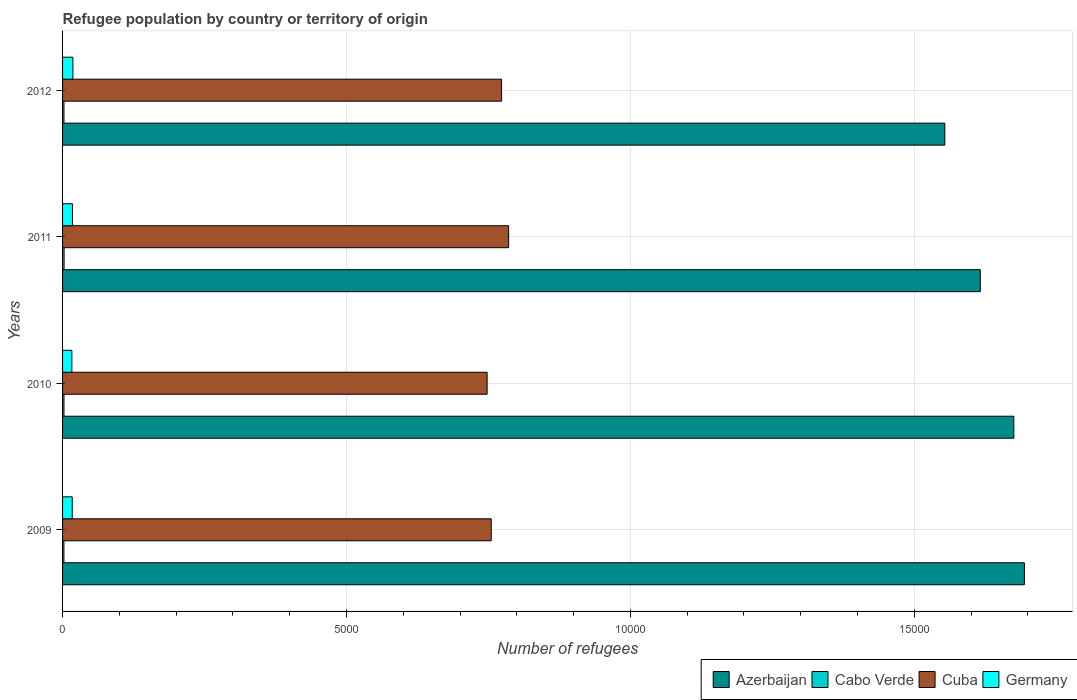How many groups of bars are there?
Keep it short and to the point. 4. Are the number of bars per tick equal to the number of legend labels?
Give a very brief answer. Yes. How many bars are there on the 3rd tick from the bottom?
Your answer should be compact. 4. What is the number of refugees in Cabo Verde in 2011?
Your answer should be very brief. 27. Across all years, what is the maximum number of refugees in Cuba?
Give a very brief answer. 7856. Across all years, what is the minimum number of refugees in Cuba?
Provide a succinct answer. 7477. In which year was the number of refugees in Germany minimum?
Your response must be concise. 2010. What is the total number of refugees in Germany in the graph?
Give a very brief answer. 690. What is the difference between the number of refugees in Cuba in 2010 and that in 2012?
Your answer should be compact. -254. What is the difference between the number of refugees in Germany in 2009 and the number of refugees in Azerbaijan in 2011?
Your answer should be very brief. -1.60e+04. What is the average number of refugees in Germany per year?
Give a very brief answer. 172.5. In the year 2009, what is the difference between the number of refugees in Azerbaijan and number of refugees in Germany?
Give a very brief answer. 1.68e+04. What is the ratio of the number of refugees in Cabo Verde in 2009 to that in 2011?
Give a very brief answer. 0.89. Is the number of refugees in Cuba in 2010 less than that in 2012?
Your answer should be compact. Yes. Is the difference between the number of refugees in Azerbaijan in 2009 and 2011 greater than the difference between the number of refugees in Germany in 2009 and 2011?
Your response must be concise. Yes. What is the difference between the highest and the second highest number of refugees in Cabo Verde?
Provide a short and direct response. 2. What is the difference between the highest and the lowest number of refugees in Cuba?
Provide a succinct answer. 379. Is it the case that in every year, the sum of the number of refugees in Cuba and number of refugees in Cabo Verde is greater than the sum of number of refugees in Germany and number of refugees in Azerbaijan?
Give a very brief answer. Yes. What does the 4th bar from the top in 2009 represents?
Your response must be concise. Azerbaijan. What does the 1st bar from the bottom in 2011 represents?
Provide a short and direct response. Azerbaijan. How many bars are there?
Your response must be concise. 16. How many years are there in the graph?
Provide a short and direct response. 4. What is the difference between two consecutive major ticks on the X-axis?
Provide a succinct answer. 5000. Does the graph contain any zero values?
Your response must be concise. No. Does the graph contain grids?
Ensure brevity in your answer.  Yes. Where does the legend appear in the graph?
Keep it short and to the point. Bottom right. What is the title of the graph?
Offer a terse response. Refugee population by country or territory of origin. What is the label or title of the X-axis?
Your answer should be very brief. Number of refugees. What is the label or title of the Y-axis?
Offer a very short reply. Years. What is the Number of refugees in Azerbaijan in 2009?
Your answer should be very brief. 1.69e+04. What is the Number of refugees in Cuba in 2009?
Keep it short and to the point. 7549. What is the Number of refugees of Germany in 2009?
Keep it short and to the point. 170. What is the Number of refugees of Azerbaijan in 2010?
Your answer should be compact. 1.68e+04. What is the Number of refugees of Cuba in 2010?
Your answer should be compact. 7477. What is the Number of refugees in Germany in 2010?
Your answer should be very brief. 164. What is the Number of refugees of Azerbaijan in 2011?
Offer a terse response. 1.62e+04. What is the Number of refugees of Cabo Verde in 2011?
Provide a succinct answer. 27. What is the Number of refugees of Cuba in 2011?
Ensure brevity in your answer.  7856. What is the Number of refugees in Germany in 2011?
Your response must be concise. 174. What is the Number of refugees of Azerbaijan in 2012?
Your answer should be compact. 1.55e+04. What is the Number of refugees in Cuba in 2012?
Your answer should be very brief. 7731. What is the Number of refugees in Germany in 2012?
Give a very brief answer. 182. Across all years, what is the maximum Number of refugees in Azerbaijan?
Offer a terse response. 1.69e+04. Across all years, what is the maximum Number of refugees in Cuba?
Keep it short and to the point. 7856. Across all years, what is the maximum Number of refugees in Germany?
Ensure brevity in your answer.  182. Across all years, what is the minimum Number of refugees in Azerbaijan?
Your response must be concise. 1.55e+04. Across all years, what is the minimum Number of refugees of Cabo Verde?
Keep it short and to the point. 24. Across all years, what is the minimum Number of refugees of Cuba?
Offer a terse response. 7477. Across all years, what is the minimum Number of refugees in Germany?
Your answer should be very brief. 164. What is the total Number of refugees of Azerbaijan in the graph?
Make the answer very short. 6.54e+04. What is the total Number of refugees of Cabo Verde in the graph?
Provide a succinct answer. 101. What is the total Number of refugees of Cuba in the graph?
Give a very brief answer. 3.06e+04. What is the total Number of refugees of Germany in the graph?
Your answer should be very brief. 690. What is the difference between the Number of refugees of Azerbaijan in 2009 and that in 2010?
Offer a very short reply. 186. What is the difference between the Number of refugees of Azerbaijan in 2009 and that in 2011?
Provide a succinct answer. 777. What is the difference between the Number of refugees in Cuba in 2009 and that in 2011?
Keep it short and to the point. -307. What is the difference between the Number of refugees of Azerbaijan in 2009 and that in 2012?
Ensure brevity in your answer.  1402. What is the difference between the Number of refugees in Cuba in 2009 and that in 2012?
Keep it short and to the point. -182. What is the difference between the Number of refugees in Germany in 2009 and that in 2012?
Keep it short and to the point. -12. What is the difference between the Number of refugees in Azerbaijan in 2010 and that in 2011?
Keep it short and to the point. 591. What is the difference between the Number of refugees of Cuba in 2010 and that in 2011?
Give a very brief answer. -379. What is the difference between the Number of refugees in Germany in 2010 and that in 2011?
Keep it short and to the point. -10. What is the difference between the Number of refugees of Azerbaijan in 2010 and that in 2012?
Ensure brevity in your answer.  1216. What is the difference between the Number of refugees of Cabo Verde in 2010 and that in 2012?
Keep it short and to the point. 0. What is the difference between the Number of refugees in Cuba in 2010 and that in 2012?
Your answer should be very brief. -254. What is the difference between the Number of refugees in Germany in 2010 and that in 2012?
Your answer should be very brief. -18. What is the difference between the Number of refugees in Azerbaijan in 2011 and that in 2012?
Your response must be concise. 625. What is the difference between the Number of refugees of Cabo Verde in 2011 and that in 2012?
Your response must be concise. 2. What is the difference between the Number of refugees in Cuba in 2011 and that in 2012?
Make the answer very short. 125. What is the difference between the Number of refugees in Azerbaijan in 2009 and the Number of refugees in Cabo Verde in 2010?
Give a very brief answer. 1.69e+04. What is the difference between the Number of refugees of Azerbaijan in 2009 and the Number of refugees of Cuba in 2010?
Make the answer very short. 9462. What is the difference between the Number of refugees of Azerbaijan in 2009 and the Number of refugees of Germany in 2010?
Your answer should be compact. 1.68e+04. What is the difference between the Number of refugees in Cabo Verde in 2009 and the Number of refugees in Cuba in 2010?
Your answer should be compact. -7453. What is the difference between the Number of refugees in Cabo Verde in 2009 and the Number of refugees in Germany in 2010?
Provide a short and direct response. -140. What is the difference between the Number of refugees in Cuba in 2009 and the Number of refugees in Germany in 2010?
Offer a terse response. 7385. What is the difference between the Number of refugees in Azerbaijan in 2009 and the Number of refugees in Cabo Verde in 2011?
Provide a short and direct response. 1.69e+04. What is the difference between the Number of refugees of Azerbaijan in 2009 and the Number of refugees of Cuba in 2011?
Offer a terse response. 9083. What is the difference between the Number of refugees in Azerbaijan in 2009 and the Number of refugees in Germany in 2011?
Offer a very short reply. 1.68e+04. What is the difference between the Number of refugees of Cabo Verde in 2009 and the Number of refugees of Cuba in 2011?
Offer a terse response. -7832. What is the difference between the Number of refugees in Cabo Verde in 2009 and the Number of refugees in Germany in 2011?
Keep it short and to the point. -150. What is the difference between the Number of refugees in Cuba in 2009 and the Number of refugees in Germany in 2011?
Provide a succinct answer. 7375. What is the difference between the Number of refugees in Azerbaijan in 2009 and the Number of refugees in Cabo Verde in 2012?
Keep it short and to the point. 1.69e+04. What is the difference between the Number of refugees in Azerbaijan in 2009 and the Number of refugees in Cuba in 2012?
Keep it short and to the point. 9208. What is the difference between the Number of refugees of Azerbaijan in 2009 and the Number of refugees of Germany in 2012?
Provide a succinct answer. 1.68e+04. What is the difference between the Number of refugees of Cabo Verde in 2009 and the Number of refugees of Cuba in 2012?
Your answer should be compact. -7707. What is the difference between the Number of refugees in Cabo Verde in 2009 and the Number of refugees in Germany in 2012?
Ensure brevity in your answer.  -158. What is the difference between the Number of refugees of Cuba in 2009 and the Number of refugees of Germany in 2012?
Provide a succinct answer. 7367. What is the difference between the Number of refugees in Azerbaijan in 2010 and the Number of refugees in Cabo Verde in 2011?
Provide a succinct answer. 1.67e+04. What is the difference between the Number of refugees of Azerbaijan in 2010 and the Number of refugees of Cuba in 2011?
Your answer should be compact. 8897. What is the difference between the Number of refugees of Azerbaijan in 2010 and the Number of refugees of Germany in 2011?
Offer a terse response. 1.66e+04. What is the difference between the Number of refugees of Cabo Verde in 2010 and the Number of refugees of Cuba in 2011?
Give a very brief answer. -7831. What is the difference between the Number of refugees of Cabo Verde in 2010 and the Number of refugees of Germany in 2011?
Your answer should be compact. -149. What is the difference between the Number of refugees in Cuba in 2010 and the Number of refugees in Germany in 2011?
Your response must be concise. 7303. What is the difference between the Number of refugees in Azerbaijan in 2010 and the Number of refugees in Cabo Verde in 2012?
Make the answer very short. 1.67e+04. What is the difference between the Number of refugees of Azerbaijan in 2010 and the Number of refugees of Cuba in 2012?
Give a very brief answer. 9022. What is the difference between the Number of refugees of Azerbaijan in 2010 and the Number of refugees of Germany in 2012?
Offer a very short reply. 1.66e+04. What is the difference between the Number of refugees of Cabo Verde in 2010 and the Number of refugees of Cuba in 2012?
Offer a very short reply. -7706. What is the difference between the Number of refugees in Cabo Verde in 2010 and the Number of refugees in Germany in 2012?
Provide a succinct answer. -157. What is the difference between the Number of refugees of Cuba in 2010 and the Number of refugees of Germany in 2012?
Provide a short and direct response. 7295. What is the difference between the Number of refugees of Azerbaijan in 2011 and the Number of refugees of Cabo Verde in 2012?
Keep it short and to the point. 1.61e+04. What is the difference between the Number of refugees in Azerbaijan in 2011 and the Number of refugees in Cuba in 2012?
Make the answer very short. 8431. What is the difference between the Number of refugees in Azerbaijan in 2011 and the Number of refugees in Germany in 2012?
Provide a short and direct response. 1.60e+04. What is the difference between the Number of refugees of Cabo Verde in 2011 and the Number of refugees of Cuba in 2012?
Keep it short and to the point. -7704. What is the difference between the Number of refugees of Cabo Verde in 2011 and the Number of refugees of Germany in 2012?
Offer a very short reply. -155. What is the difference between the Number of refugees in Cuba in 2011 and the Number of refugees in Germany in 2012?
Keep it short and to the point. 7674. What is the average Number of refugees of Azerbaijan per year?
Your answer should be very brief. 1.63e+04. What is the average Number of refugees in Cabo Verde per year?
Ensure brevity in your answer.  25.25. What is the average Number of refugees of Cuba per year?
Offer a very short reply. 7653.25. What is the average Number of refugees in Germany per year?
Your response must be concise. 172.5. In the year 2009, what is the difference between the Number of refugees in Azerbaijan and Number of refugees in Cabo Verde?
Your response must be concise. 1.69e+04. In the year 2009, what is the difference between the Number of refugees in Azerbaijan and Number of refugees in Cuba?
Provide a short and direct response. 9390. In the year 2009, what is the difference between the Number of refugees in Azerbaijan and Number of refugees in Germany?
Ensure brevity in your answer.  1.68e+04. In the year 2009, what is the difference between the Number of refugees of Cabo Verde and Number of refugees of Cuba?
Provide a succinct answer. -7525. In the year 2009, what is the difference between the Number of refugees in Cabo Verde and Number of refugees in Germany?
Offer a very short reply. -146. In the year 2009, what is the difference between the Number of refugees of Cuba and Number of refugees of Germany?
Keep it short and to the point. 7379. In the year 2010, what is the difference between the Number of refugees in Azerbaijan and Number of refugees in Cabo Verde?
Your answer should be compact. 1.67e+04. In the year 2010, what is the difference between the Number of refugees of Azerbaijan and Number of refugees of Cuba?
Give a very brief answer. 9276. In the year 2010, what is the difference between the Number of refugees in Azerbaijan and Number of refugees in Germany?
Your response must be concise. 1.66e+04. In the year 2010, what is the difference between the Number of refugees of Cabo Verde and Number of refugees of Cuba?
Your answer should be very brief. -7452. In the year 2010, what is the difference between the Number of refugees of Cabo Verde and Number of refugees of Germany?
Provide a succinct answer. -139. In the year 2010, what is the difference between the Number of refugees in Cuba and Number of refugees in Germany?
Your answer should be compact. 7313. In the year 2011, what is the difference between the Number of refugees in Azerbaijan and Number of refugees in Cabo Verde?
Provide a short and direct response. 1.61e+04. In the year 2011, what is the difference between the Number of refugees of Azerbaijan and Number of refugees of Cuba?
Give a very brief answer. 8306. In the year 2011, what is the difference between the Number of refugees of Azerbaijan and Number of refugees of Germany?
Your response must be concise. 1.60e+04. In the year 2011, what is the difference between the Number of refugees of Cabo Verde and Number of refugees of Cuba?
Make the answer very short. -7829. In the year 2011, what is the difference between the Number of refugees in Cabo Verde and Number of refugees in Germany?
Your response must be concise. -147. In the year 2011, what is the difference between the Number of refugees in Cuba and Number of refugees in Germany?
Make the answer very short. 7682. In the year 2012, what is the difference between the Number of refugees of Azerbaijan and Number of refugees of Cabo Verde?
Keep it short and to the point. 1.55e+04. In the year 2012, what is the difference between the Number of refugees in Azerbaijan and Number of refugees in Cuba?
Offer a terse response. 7806. In the year 2012, what is the difference between the Number of refugees in Azerbaijan and Number of refugees in Germany?
Give a very brief answer. 1.54e+04. In the year 2012, what is the difference between the Number of refugees of Cabo Verde and Number of refugees of Cuba?
Keep it short and to the point. -7706. In the year 2012, what is the difference between the Number of refugees in Cabo Verde and Number of refugees in Germany?
Keep it short and to the point. -157. In the year 2012, what is the difference between the Number of refugees of Cuba and Number of refugees of Germany?
Your answer should be compact. 7549. What is the ratio of the Number of refugees of Azerbaijan in 2009 to that in 2010?
Your answer should be very brief. 1.01. What is the ratio of the Number of refugees in Cabo Verde in 2009 to that in 2010?
Provide a succinct answer. 0.96. What is the ratio of the Number of refugees in Cuba in 2009 to that in 2010?
Make the answer very short. 1.01. What is the ratio of the Number of refugees in Germany in 2009 to that in 2010?
Your response must be concise. 1.04. What is the ratio of the Number of refugees of Azerbaijan in 2009 to that in 2011?
Your answer should be very brief. 1.05. What is the ratio of the Number of refugees of Cuba in 2009 to that in 2011?
Offer a very short reply. 0.96. What is the ratio of the Number of refugees in Azerbaijan in 2009 to that in 2012?
Keep it short and to the point. 1.09. What is the ratio of the Number of refugees of Cuba in 2009 to that in 2012?
Give a very brief answer. 0.98. What is the ratio of the Number of refugees in Germany in 2009 to that in 2012?
Give a very brief answer. 0.93. What is the ratio of the Number of refugees of Azerbaijan in 2010 to that in 2011?
Keep it short and to the point. 1.04. What is the ratio of the Number of refugees of Cabo Verde in 2010 to that in 2011?
Make the answer very short. 0.93. What is the ratio of the Number of refugees of Cuba in 2010 to that in 2011?
Make the answer very short. 0.95. What is the ratio of the Number of refugees of Germany in 2010 to that in 2011?
Your answer should be compact. 0.94. What is the ratio of the Number of refugees of Azerbaijan in 2010 to that in 2012?
Offer a very short reply. 1.08. What is the ratio of the Number of refugees of Cuba in 2010 to that in 2012?
Ensure brevity in your answer.  0.97. What is the ratio of the Number of refugees of Germany in 2010 to that in 2012?
Ensure brevity in your answer.  0.9. What is the ratio of the Number of refugees of Azerbaijan in 2011 to that in 2012?
Provide a succinct answer. 1.04. What is the ratio of the Number of refugees in Cabo Verde in 2011 to that in 2012?
Offer a terse response. 1.08. What is the ratio of the Number of refugees in Cuba in 2011 to that in 2012?
Your answer should be compact. 1.02. What is the ratio of the Number of refugees of Germany in 2011 to that in 2012?
Your answer should be very brief. 0.96. What is the difference between the highest and the second highest Number of refugees in Azerbaijan?
Offer a terse response. 186. What is the difference between the highest and the second highest Number of refugees in Cabo Verde?
Your answer should be very brief. 2. What is the difference between the highest and the second highest Number of refugees of Cuba?
Ensure brevity in your answer.  125. What is the difference between the highest and the lowest Number of refugees of Azerbaijan?
Your answer should be very brief. 1402. What is the difference between the highest and the lowest Number of refugees in Cabo Verde?
Give a very brief answer. 3. What is the difference between the highest and the lowest Number of refugees in Cuba?
Ensure brevity in your answer.  379. 